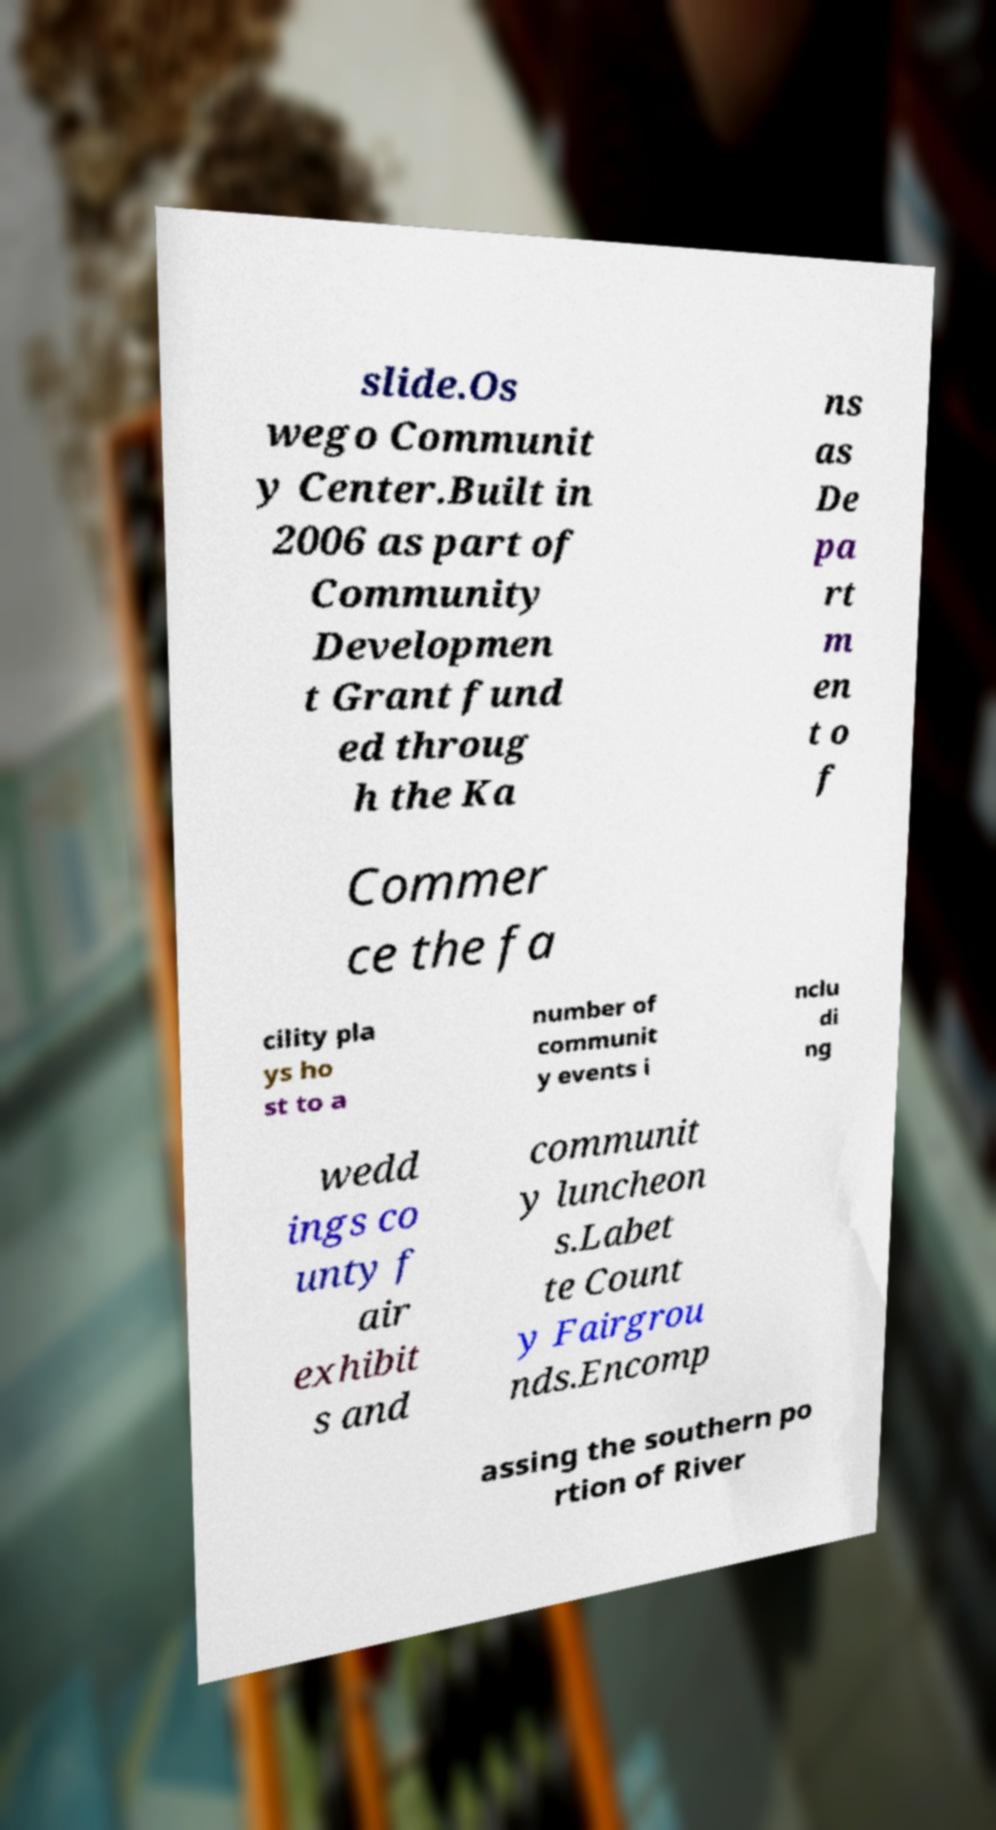Can you read and provide the text displayed in the image?This photo seems to have some interesting text. Can you extract and type it out for me? slide.Os wego Communit y Center.Built in 2006 as part of Community Developmen t Grant fund ed throug h the Ka ns as De pa rt m en t o f Commer ce the fa cility pla ys ho st to a number of communit y events i nclu di ng wedd ings co unty f air exhibit s and communit y luncheon s.Labet te Count y Fairgrou nds.Encomp assing the southern po rtion of River 